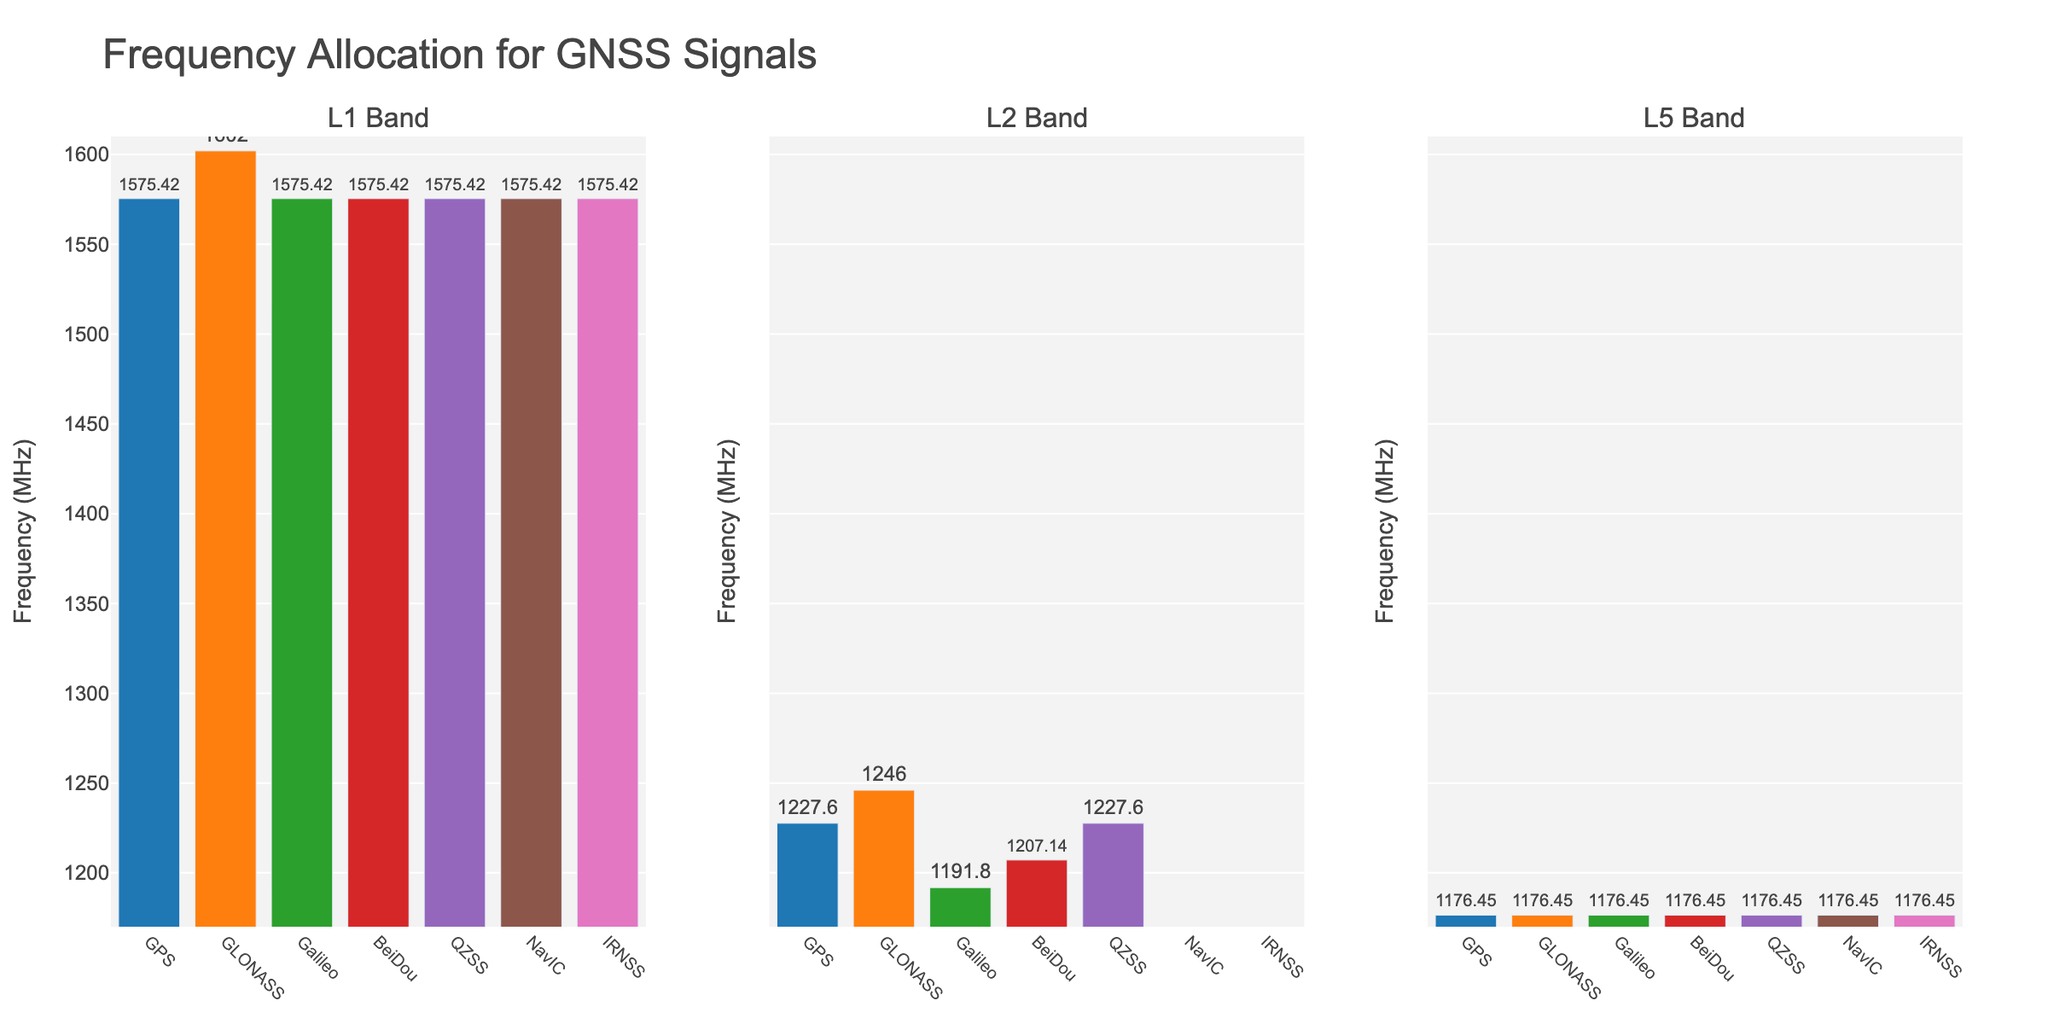Which GNSS system does not have an L2 Band allocation? According to the figure, only NavIC and IRNSS have no bars in the L2 Band column.
Answer: NavIC, IRNSS Which GNSS systems share the same L5 Band frequency allocation? All GNSS systems have a bar at the same height in the L5 Band column, indicating they share the same frequency of 1176.45 MHz.
Answer: All systems Compare the L1 Band frequencies. Which system has the highest L1 frequency? By comparing the height of the bars in the L1 Band column, GLONASS is the highest.
Answer: GLONASS What is the difference in frequency allocation between GLONASS and other systems in the L1 Band? GLONASS has a height different from the rest. The L1 Band frequency for GLONASS is 1602 MHz, while others have 1575.42 MHz. The difference is 1602 - 1575.42.
Answer: 26.58 MHz How many systems have identical L2 Band frequencies? From the L2 Band column, there are bars at 1227.60 MHz for GPS and QZSS.
Answer: 2 systems Calculate the average frequency for the L1 Band across all systems. Sum all L1 Band frequencies: (1575.42 + 1602.00 + 1575.42 + 1575.42 + 1575.42 + 1575.42 + 1575.42) = 11054.94. The average is 11054.94 / 7.
Answer: 1579.28 MHz For the L5 Band, which color bar represents NavIC? All bars in the L5 Band column are at the same height. The corresponding color for NavIC needs identification and matching from the legend.
Answer: (Color of NavIC in the L5 Band column, e.g., red) Compare Galileo and BeiDou in term of their L2 Band frequencies. Which one is allocated a higher frequency? In the L2 Band column, Galileo's frequency is 1191.795 MHz, and BeiDou's is 1207.14 MHz.
Answer: BeiDou If the frequency allocations were sorted in ascending order, which system would appear last in the L1 Band list? The highest frequency in the L1 Band list corresponds to GLONASS at 1602 MHz.
Answer: GLONASS 